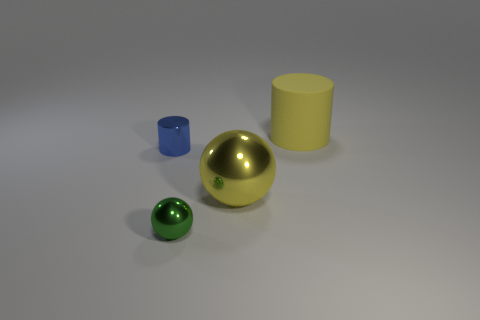How many shiny balls have the same color as the big matte thing?
Your answer should be compact. 1. There is a yellow object that is in front of the yellow rubber cylinder; what is its size?
Make the answer very short. Large. How many yellow metal objects have the same size as the rubber object?
Your answer should be very brief. 1. The other small thing that is the same material as the green thing is what color?
Your answer should be very brief. Blue. Is the number of yellow shiny balls that are in front of the yellow ball less than the number of big shiny blocks?
Keep it short and to the point. No. The blue thing that is made of the same material as the big sphere is what shape?
Provide a succinct answer. Cylinder. What number of shiny objects are large gray things or big cylinders?
Give a very brief answer. 0. Are there an equal number of small green things in front of the tiny green metal thing and yellow cylinders?
Keep it short and to the point. No. There is a cylinder that is on the left side of the green metallic sphere; is its color the same as the big matte cylinder?
Your answer should be very brief. No. There is a object that is in front of the tiny blue shiny object and behind the tiny metallic sphere; what material is it made of?
Provide a succinct answer. Metal. 